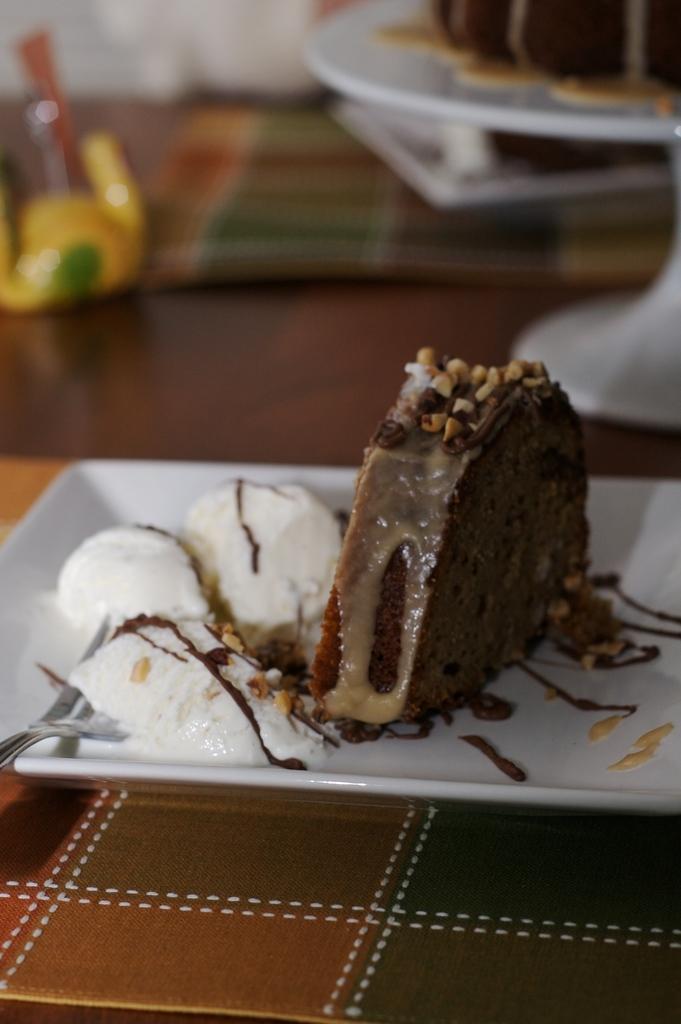Describe this image in one or two sentences. In this image there is a slice of a cake and ice cream scoops with nuts and a fork on the plate, and in the background there is a cake on the circular cake stand and an object on the table. 